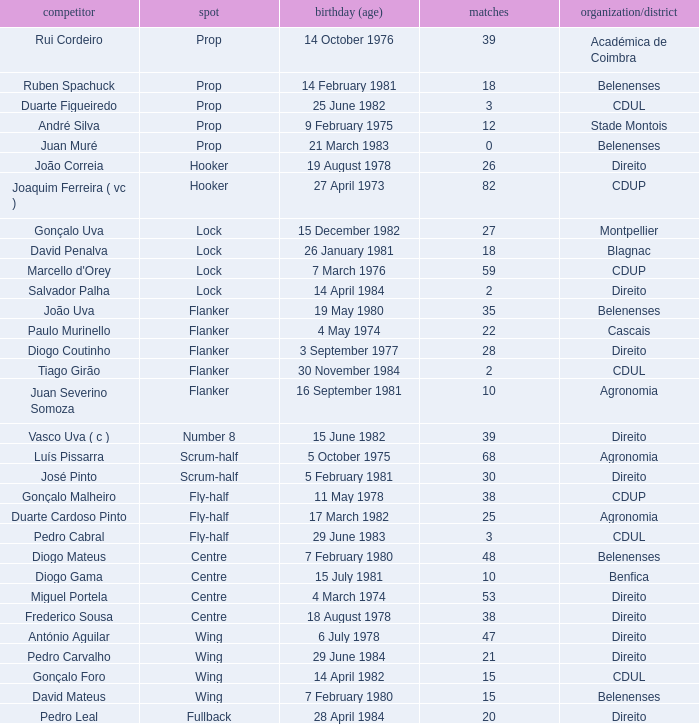Which Club/province has a Player of david penalva? Blagnac. 